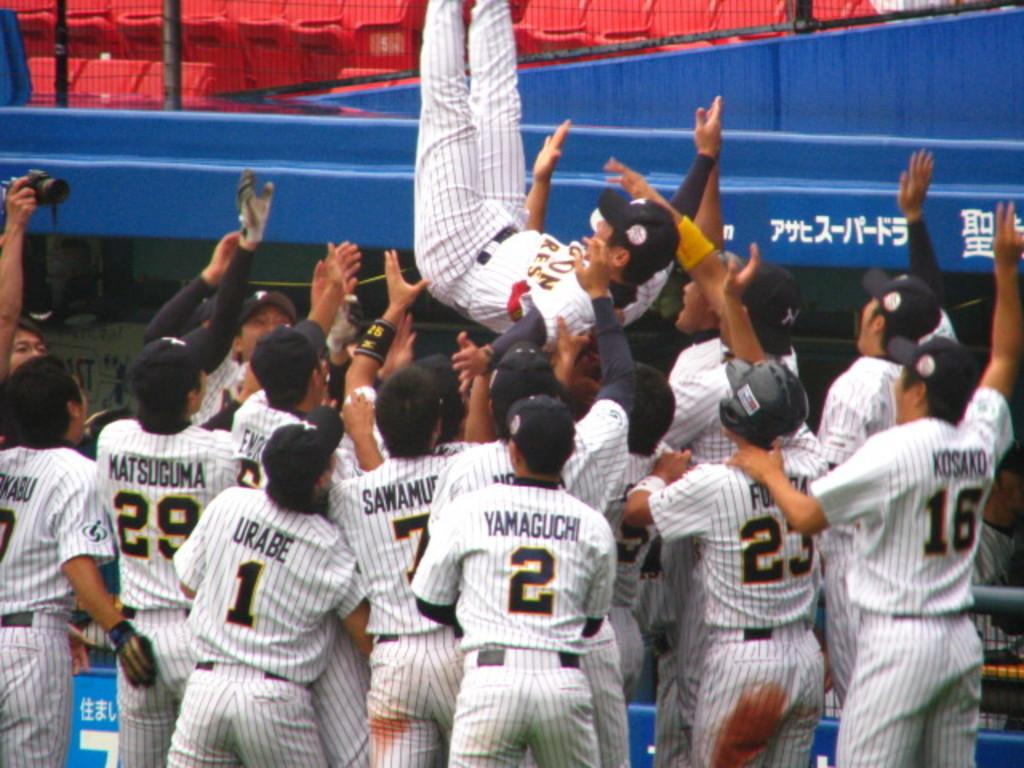<image>
Give a short and clear explanation of the subsequent image. Baseball players including Matsuguma, Urabe and Yamaguchi celebrate with teammates. 